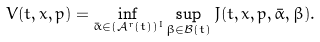Convert formula to latex. <formula><loc_0><loc_0><loc_500><loc_500>V ( t , x , p ) = \inf _ { \bar { \alpha } \in ( \mathcal { A } ^ { r } ( t ) ) ^ { I } } \sup _ { \beta \in \mathcal { B } ( t ) } J ( t , x , p , \bar { \alpha } , \beta ) .</formula> 